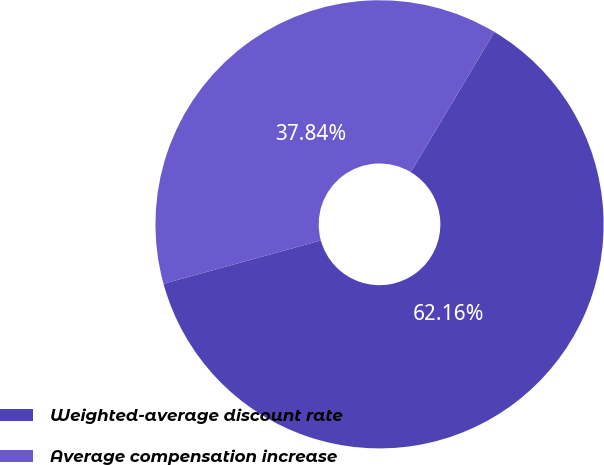Convert chart to OTSL. <chart><loc_0><loc_0><loc_500><loc_500><pie_chart><fcel>Weighted-average discount rate<fcel>Average compensation increase<nl><fcel>62.16%<fcel>37.84%<nl></chart> 